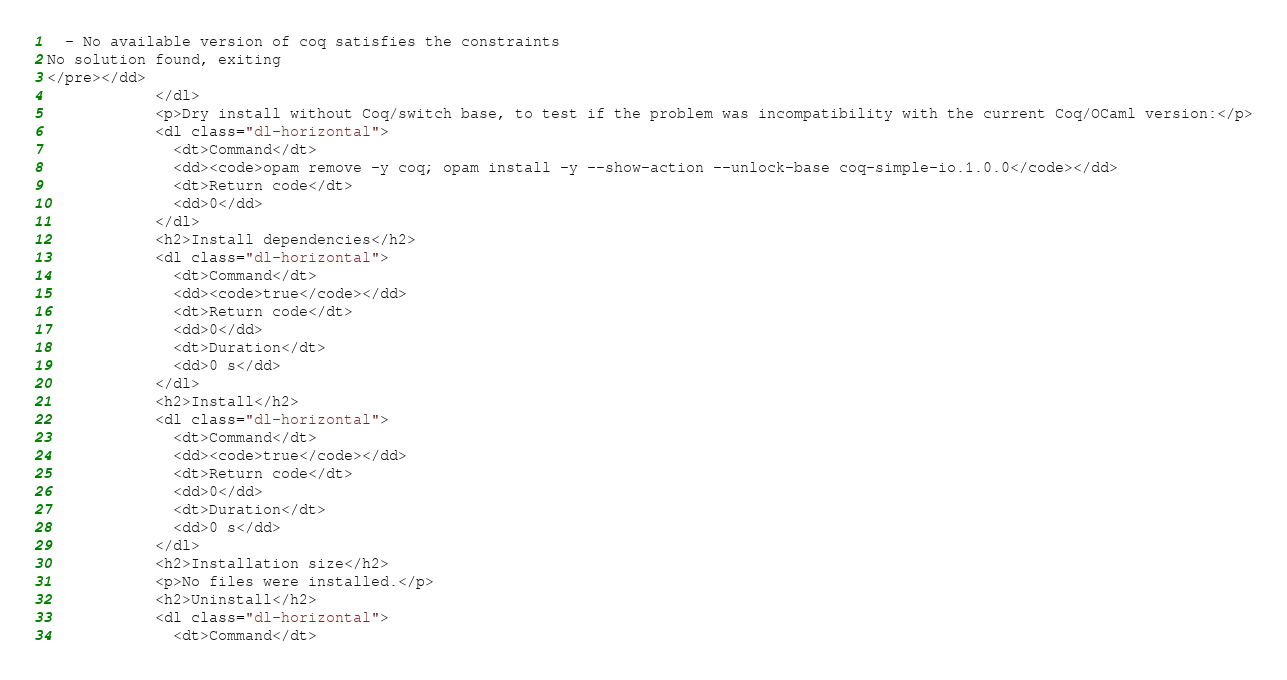<code> <loc_0><loc_0><loc_500><loc_500><_HTML_>  - No available version of coq satisfies the constraints
No solution found, exiting
</pre></dd>
            </dl>
            <p>Dry install without Coq/switch base, to test if the problem was incompatibility with the current Coq/OCaml version:</p>
            <dl class="dl-horizontal">
              <dt>Command</dt>
              <dd><code>opam remove -y coq; opam install -y --show-action --unlock-base coq-simple-io.1.0.0</code></dd>
              <dt>Return code</dt>
              <dd>0</dd>
            </dl>
            <h2>Install dependencies</h2>
            <dl class="dl-horizontal">
              <dt>Command</dt>
              <dd><code>true</code></dd>
              <dt>Return code</dt>
              <dd>0</dd>
              <dt>Duration</dt>
              <dd>0 s</dd>
            </dl>
            <h2>Install</h2>
            <dl class="dl-horizontal">
              <dt>Command</dt>
              <dd><code>true</code></dd>
              <dt>Return code</dt>
              <dd>0</dd>
              <dt>Duration</dt>
              <dd>0 s</dd>
            </dl>
            <h2>Installation size</h2>
            <p>No files were installed.</p>
            <h2>Uninstall</h2>
            <dl class="dl-horizontal">
              <dt>Command</dt></code> 